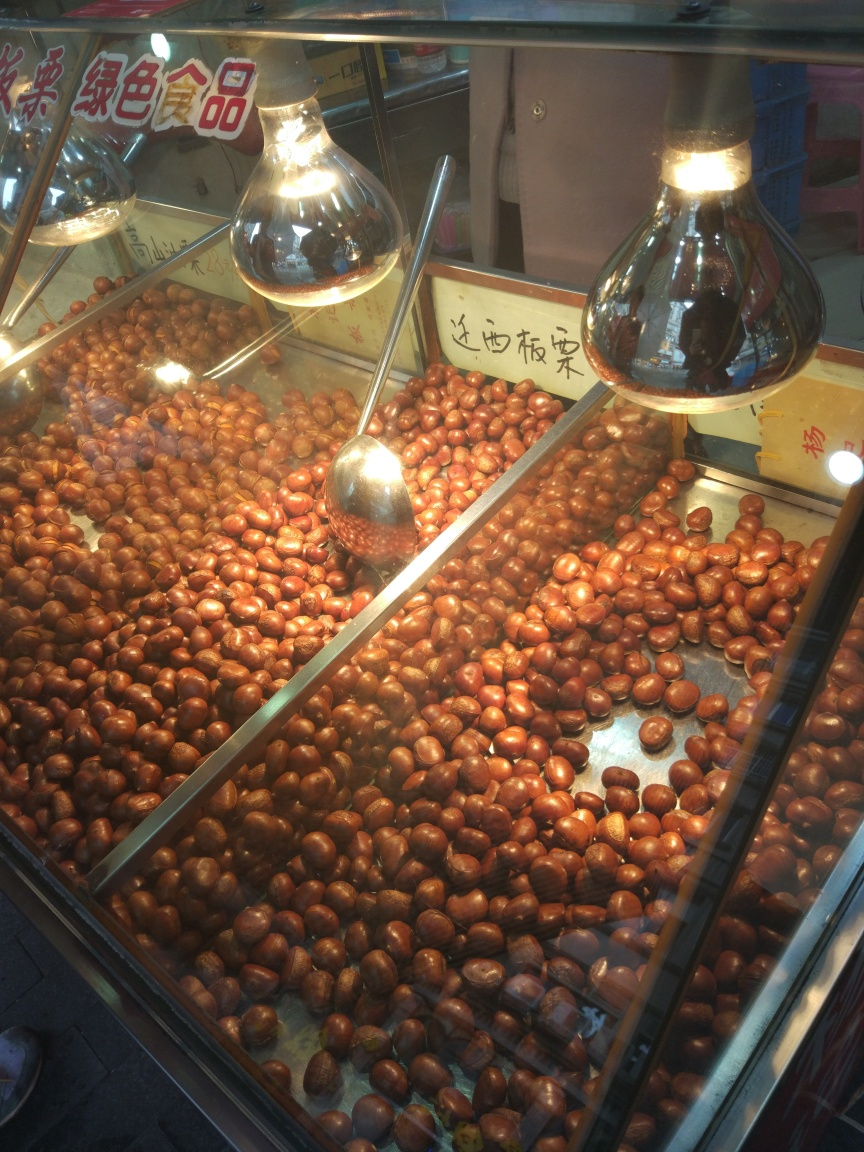Is the text clear and readable?
A. No
B. Yes
Answer with the option's letter from the given choices directly.
 B. 